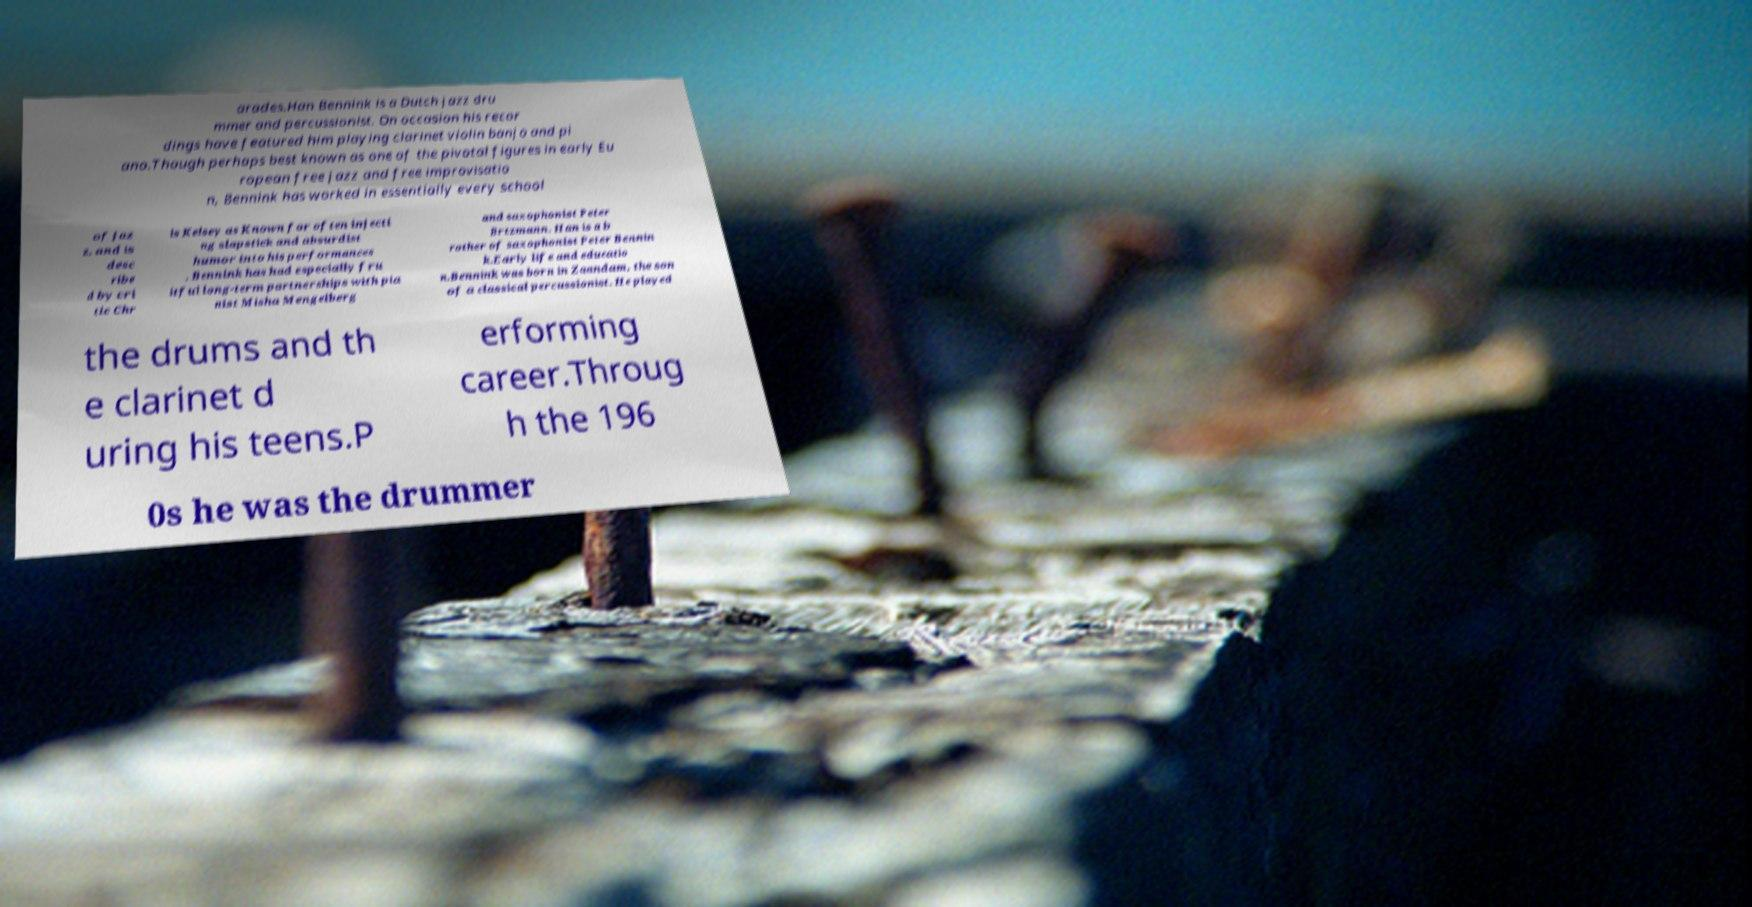Please identify and transcribe the text found in this image. arades.Han Bennink is a Dutch jazz dru mmer and percussionist. On occasion his recor dings have featured him playing clarinet violin banjo and pi ano.Though perhaps best known as one of the pivotal figures in early Eu ropean free jazz and free improvisatio n, Bennink has worked in essentially every school of jaz z, and is desc ribe d by cri tic Chr is Kelsey as Known for often injecti ng slapstick and absurdist humor into his performances , Bennink has had especially fru itful long-term partnerships with pia nist Misha Mengelberg and saxophonist Peter Brtzmann. Han is a b rother of saxophonist Peter Bennin k.Early life and educatio n.Bennink was born in Zaandam, the son of a classical percussionist. He played the drums and th e clarinet d uring his teens.P erforming career.Throug h the 196 0s he was the drummer 